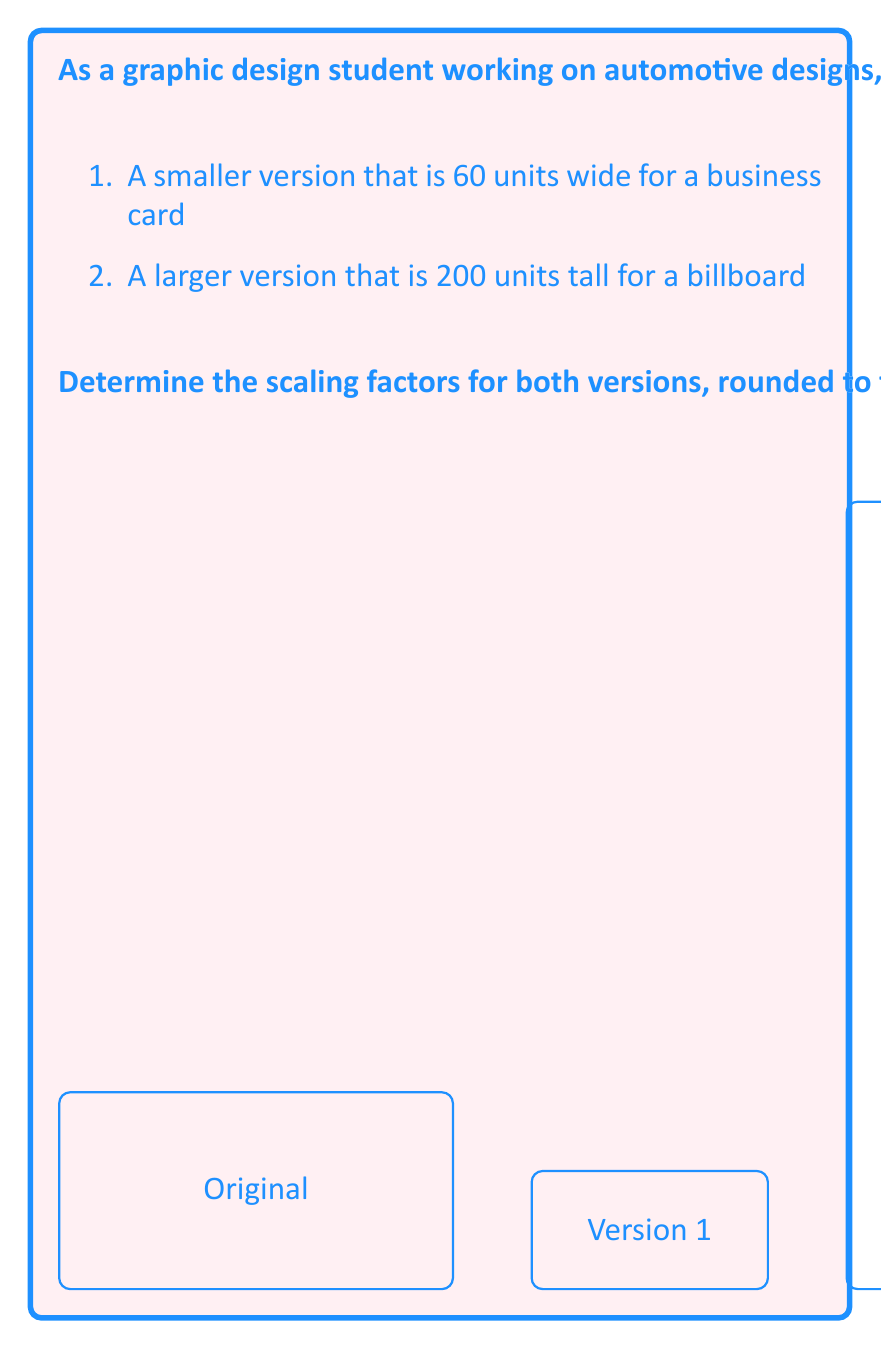What is the answer to this math problem? To determine the scaling factors, we need to calculate the ratio of the new dimensions to the original dimensions.

For Version 1 (smaller version):
1. Given width: 60 units
2. Original width: 100 units
3. Scaling factor = New width / Original width
   $$ \text{Scaling factor}_1 = \frac{60}{100} = 0.6 $$

For Version 2 (larger version):
1. Given height: 200 units
2. Original height: 50 units
3. Scaling factor = New height / Original height
   $$ \text{Scaling factor}_2 = \frac{200}{50} = 4 $$

Both scaling factors are already rounded to two decimal places.

Note: In vector graphics, scaling is uniform, meaning the aspect ratio is maintained. Therefore, applying these scaling factors to both dimensions of the original logo will result in the desired sizes while preserving the logo's proportions.
Answer: 0.60 and 4.00 